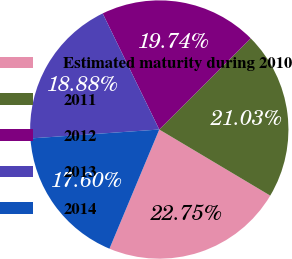<chart> <loc_0><loc_0><loc_500><loc_500><pie_chart><fcel>Estimated maturity during 2010<fcel>2011<fcel>2012<fcel>2013<fcel>2014<nl><fcel>22.75%<fcel>21.03%<fcel>19.74%<fcel>18.88%<fcel>17.6%<nl></chart> 